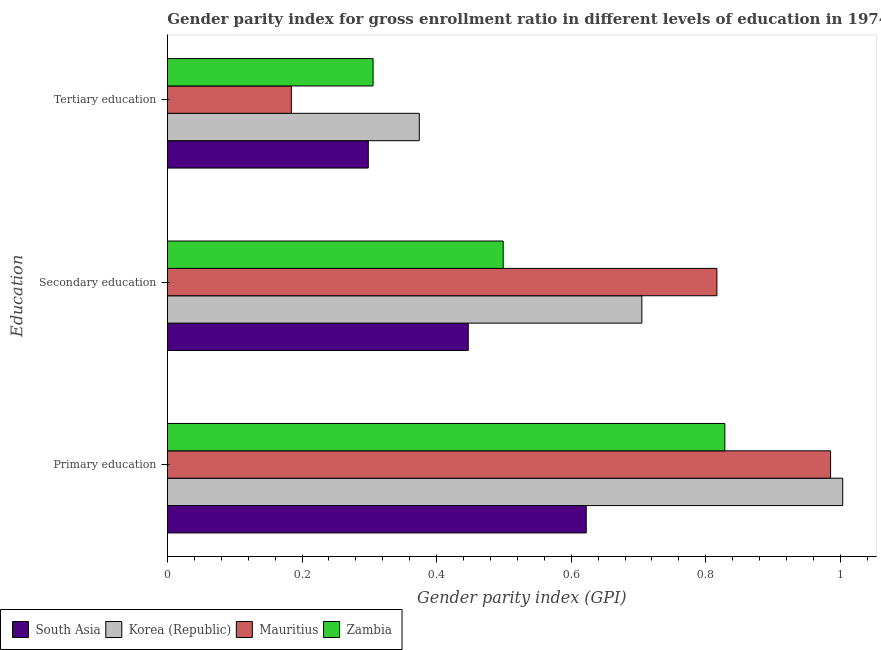How many groups of bars are there?
Your response must be concise. 3. How many bars are there on the 3rd tick from the top?
Ensure brevity in your answer.  4. How many bars are there on the 2nd tick from the bottom?
Give a very brief answer. 4. What is the label of the 2nd group of bars from the top?
Your answer should be very brief. Secondary education. What is the gender parity index in tertiary education in South Asia?
Provide a short and direct response. 0.3. Across all countries, what is the maximum gender parity index in tertiary education?
Your response must be concise. 0.37. Across all countries, what is the minimum gender parity index in tertiary education?
Your answer should be very brief. 0.18. In which country was the gender parity index in tertiary education maximum?
Provide a short and direct response. Korea (Republic). In which country was the gender parity index in tertiary education minimum?
Offer a very short reply. Mauritius. What is the total gender parity index in tertiary education in the graph?
Your answer should be compact. 1.16. What is the difference between the gender parity index in tertiary education in South Asia and that in Mauritius?
Offer a very short reply. 0.11. What is the difference between the gender parity index in secondary education in Zambia and the gender parity index in tertiary education in South Asia?
Make the answer very short. 0.2. What is the average gender parity index in secondary education per country?
Ensure brevity in your answer.  0.62. What is the difference between the gender parity index in secondary education and gender parity index in primary education in Mauritius?
Give a very brief answer. -0.17. In how many countries, is the gender parity index in secondary education greater than 0.68 ?
Your answer should be compact. 2. What is the ratio of the gender parity index in tertiary education in Korea (Republic) to that in Zambia?
Provide a succinct answer. 1.22. What is the difference between the highest and the second highest gender parity index in tertiary education?
Offer a terse response. 0.07. What is the difference between the highest and the lowest gender parity index in secondary education?
Provide a succinct answer. 0.37. In how many countries, is the gender parity index in tertiary education greater than the average gender parity index in tertiary education taken over all countries?
Provide a succinct answer. 3. Is the sum of the gender parity index in tertiary education in Zambia and Mauritius greater than the maximum gender parity index in secondary education across all countries?
Offer a terse response. No. What does the 1st bar from the top in Primary education represents?
Offer a terse response. Zambia. What does the 4th bar from the bottom in Primary education represents?
Provide a short and direct response. Zambia. Is it the case that in every country, the sum of the gender parity index in primary education and gender parity index in secondary education is greater than the gender parity index in tertiary education?
Your response must be concise. Yes. Are all the bars in the graph horizontal?
Offer a terse response. Yes. How many countries are there in the graph?
Give a very brief answer. 4. Are the values on the major ticks of X-axis written in scientific E-notation?
Keep it short and to the point. No. Does the graph contain any zero values?
Ensure brevity in your answer.  No. How many legend labels are there?
Offer a terse response. 4. What is the title of the graph?
Offer a terse response. Gender parity index for gross enrollment ratio in different levels of education in 1974. Does "Central African Republic" appear as one of the legend labels in the graph?
Your answer should be very brief. No. What is the label or title of the X-axis?
Keep it short and to the point. Gender parity index (GPI). What is the label or title of the Y-axis?
Make the answer very short. Education. What is the Gender parity index (GPI) in South Asia in Primary education?
Keep it short and to the point. 0.62. What is the Gender parity index (GPI) of Korea (Republic) in Primary education?
Provide a succinct answer. 1. What is the Gender parity index (GPI) of Mauritius in Primary education?
Your answer should be very brief. 0.99. What is the Gender parity index (GPI) of Zambia in Primary education?
Provide a short and direct response. 0.83. What is the Gender parity index (GPI) in South Asia in Secondary education?
Offer a terse response. 0.45. What is the Gender parity index (GPI) of Korea (Republic) in Secondary education?
Provide a short and direct response. 0.7. What is the Gender parity index (GPI) of Mauritius in Secondary education?
Provide a short and direct response. 0.82. What is the Gender parity index (GPI) of Zambia in Secondary education?
Ensure brevity in your answer.  0.5. What is the Gender parity index (GPI) of South Asia in Tertiary education?
Offer a terse response. 0.3. What is the Gender parity index (GPI) in Korea (Republic) in Tertiary education?
Your answer should be compact. 0.37. What is the Gender parity index (GPI) in Mauritius in Tertiary education?
Offer a terse response. 0.18. What is the Gender parity index (GPI) in Zambia in Tertiary education?
Give a very brief answer. 0.31. Across all Education, what is the maximum Gender parity index (GPI) in South Asia?
Your response must be concise. 0.62. Across all Education, what is the maximum Gender parity index (GPI) of Korea (Republic)?
Your answer should be compact. 1. Across all Education, what is the maximum Gender parity index (GPI) in Mauritius?
Offer a terse response. 0.99. Across all Education, what is the maximum Gender parity index (GPI) in Zambia?
Keep it short and to the point. 0.83. Across all Education, what is the minimum Gender parity index (GPI) in South Asia?
Give a very brief answer. 0.3. Across all Education, what is the minimum Gender parity index (GPI) of Korea (Republic)?
Offer a very short reply. 0.37. Across all Education, what is the minimum Gender parity index (GPI) of Mauritius?
Provide a succinct answer. 0.18. Across all Education, what is the minimum Gender parity index (GPI) in Zambia?
Provide a short and direct response. 0.31. What is the total Gender parity index (GPI) of South Asia in the graph?
Your answer should be compact. 1.37. What is the total Gender parity index (GPI) of Korea (Republic) in the graph?
Your answer should be compact. 2.08. What is the total Gender parity index (GPI) of Mauritius in the graph?
Your answer should be compact. 1.99. What is the total Gender parity index (GPI) in Zambia in the graph?
Provide a succinct answer. 1.63. What is the difference between the Gender parity index (GPI) in South Asia in Primary education and that in Secondary education?
Keep it short and to the point. 0.18. What is the difference between the Gender parity index (GPI) of Korea (Republic) in Primary education and that in Secondary education?
Offer a very short reply. 0.3. What is the difference between the Gender parity index (GPI) in Mauritius in Primary education and that in Secondary education?
Your response must be concise. 0.17. What is the difference between the Gender parity index (GPI) in Zambia in Primary education and that in Secondary education?
Make the answer very short. 0.33. What is the difference between the Gender parity index (GPI) in South Asia in Primary education and that in Tertiary education?
Give a very brief answer. 0.32. What is the difference between the Gender parity index (GPI) in Korea (Republic) in Primary education and that in Tertiary education?
Your answer should be very brief. 0.63. What is the difference between the Gender parity index (GPI) of Mauritius in Primary education and that in Tertiary education?
Provide a succinct answer. 0.8. What is the difference between the Gender parity index (GPI) in Zambia in Primary education and that in Tertiary education?
Your answer should be very brief. 0.52. What is the difference between the Gender parity index (GPI) of South Asia in Secondary education and that in Tertiary education?
Make the answer very short. 0.15. What is the difference between the Gender parity index (GPI) of Korea (Republic) in Secondary education and that in Tertiary education?
Offer a very short reply. 0.33. What is the difference between the Gender parity index (GPI) in Mauritius in Secondary education and that in Tertiary education?
Give a very brief answer. 0.63. What is the difference between the Gender parity index (GPI) of Zambia in Secondary education and that in Tertiary education?
Keep it short and to the point. 0.19. What is the difference between the Gender parity index (GPI) in South Asia in Primary education and the Gender parity index (GPI) in Korea (Republic) in Secondary education?
Your response must be concise. -0.08. What is the difference between the Gender parity index (GPI) in South Asia in Primary education and the Gender parity index (GPI) in Mauritius in Secondary education?
Provide a short and direct response. -0.19. What is the difference between the Gender parity index (GPI) of South Asia in Primary education and the Gender parity index (GPI) of Zambia in Secondary education?
Ensure brevity in your answer.  0.12. What is the difference between the Gender parity index (GPI) of Korea (Republic) in Primary education and the Gender parity index (GPI) of Mauritius in Secondary education?
Provide a short and direct response. 0.19. What is the difference between the Gender parity index (GPI) in Korea (Republic) in Primary education and the Gender parity index (GPI) in Zambia in Secondary education?
Provide a short and direct response. 0.5. What is the difference between the Gender parity index (GPI) of Mauritius in Primary education and the Gender parity index (GPI) of Zambia in Secondary education?
Offer a terse response. 0.49. What is the difference between the Gender parity index (GPI) in South Asia in Primary education and the Gender parity index (GPI) in Korea (Republic) in Tertiary education?
Provide a succinct answer. 0.25. What is the difference between the Gender parity index (GPI) of South Asia in Primary education and the Gender parity index (GPI) of Mauritius in Tertiary education?
Your answer should be compact. 0.44. What is the difference between the Gender parity index (GPI) in South Asia in Primary education and the Gender parity index (GPI) in Zambia in Tertiary education?
Your response must be concise. 0.32. What is the difference between the Gender parity index (GPI) of Korea (Republic) in Primary education and the Gender parity index (GPI) of Mauritius in Tertiary education?
Offer a terse response. 0.82. What is the difference between the Gender parity index (GPI) in Korea (Republic) in Primary education and the Gender parity index (GPI) in Zambia in Tertiary education?
Your answer should be very brief. 0.7. What is the difference between the Gender parity index (GPI) in Mauritius in Primary education and the Gender parity index (GPI) in Zambia in Tertiary education?
Provide a succinct answer. 0.68. What is the difference between the Gender parity index (GPI) in South Asia in Secondary education and the Gender parity index (GPI) in Korea (Republic) in Tertiary education?
Offer a very short reply. 0.07. What is the difference between the Gender parity index (GPI) in South Asia in Secondary education and the Gender parity index (GPI) in Mauritius in Tertiary education?
Ensure brevity in your answer.  0.26. What is the difference between the Gender parity index (GPI) in South Asia in Secondary education and the Gender parity index (GPI) in Zambia in Tertiary education?
Your answer should be very brief. 0.14. What is the difference between the Gender parity index (GPI) in Korea (Republic) in Secondary education and the Gender parity index (GPI) in Mauritius in Tertiary education?
Make the answer very short. 0.52. What is the difference between the Gender parity index (GPI) in Korea (Republic) in Secondary education and the Gender parity index (GPI) in Zambia in Tertiary education?
Your answer should be compact. 0.4. What is the difference between the Gender parity index (GPI) in Mauritius in Secondary education and the Gender parity index (GPI) in Zambia in Tertiary education?
Make the answer very short. 0.51. What is the average Gender parity index (GPI) of South Asia per Education?
Your answer should be compact. 0.46. What is the average Gender parity index (GPI) in Korea (Republic) per Education?
Keep it short and to the point. 0.69. What is the average Gender parity index (GPI) of Mauritius per Education?
Offer a very short reply. 0.66. What is the average Gender parity index (GPI) of Zambia per Education?
Offer a terse response. 0.54. What is the difference between the Gender parity index (GPI) in South Asia and Gender parity index (GPI) in Korea (Republic) in Primary education?
Give a very brief answer. -0.38. What is the difference between the Gender parity index (GPI) of South Asia and Gender parity index (GPI) of Mauritius in Primary education?
Ensure brevity in your answer.  -0.36. What is the difference between the Gender parity index (GPI) of South Asia and Gender parity index (GPI) of Zambia in Primary education?
Your response must be concise. -0.21. What is the difference between the Gender parity index (GPI) in Korea (Republic) and Gender parity index (GPI) in Mauritius in Primary education?
Keep it short and to the point. 0.02. What is the difference between the Gender parity index (GPI) in Korea (Republic) and Gender parity index (GPI) in Zambia in Primary education?
Make the answer very short. 0.18. What is the difference between the Gender parity index (GPI) of Mauritius and Gender parity index (GPI) of Zambia in Primary education?
Make the answer very short. 0.16. What is the difference between the Gender parity index (GPI) in South Asia and Gender parity index (GPI) in Korea (Republic) in Secondary education?
Offer a terse response. -0.26. What is the difference between the Gender parity index (GPI) in South Asia and Gender parity index (GPI) in Mauritius in Secondary education?
Your answer should be very brief. -0.37. What is the difference between the Gender parity index (GPI) of South Asia and Gender parity index (GPI) of Zambia in Secondary education?
Your answer should be compact. -0.05. What is the difference between the Gender parity index (GPI) in Korea (Republic) and Gender parity index (GPI) in Mauritius in Secondary education?
Offer a terse response. -0.11. What is the difference between the Gender parity index (GPI) in Korea (Republic) and Gender parity index (GPI) in Zambia in Secondary education?
Make the answer very short. 0.21. What is the difference between the Gender parity index (GPI) in Mauritius and Gender parity index (GPI) in Zambia in Secondary education?
Your response must be concise. 0.32. What is the difference between the Gender parity index (GPI) in South Asia and Gender parity index (GPI) in Korea (Republic) in Tertiary education?
Your answer should be very brief. -0.08. What is the difference between the Gender parity index (GPI) of South Asia and Gender parity index (GPI) of Mauritius in Tertiary education?
Your response must be concise. 0.11. What is the difference between the Gender parity index (GPI) of South Asia and Gender parity index (GPI) of Zambia in Tertiary education?
Provide a succinct answer. -0.01. What is the difference between the Gender parity index (GPI) of Korea (Republic) and Gender parity index (GPI) of Mauritius in Tertiary education?
Give a very brief answer. 0.19. What is the difference between the Gender parity index (GPI) of Korea (Republic) and Gender parity index (GPI) of Zambia in Tertiary education?
Provide a succinct answer. 0.07. What is the difference between the Gender parity index (GPI) of Mauritius and Gender parity index (GPI) of Zambia in Tertiary education?
Ensure brevity in your answer.  -0.12. What is the ratio of the Gender parity index (GPI) of South Asia in Primary education to that in Secondary education?
Your response must be concise. 1.39. What is the ratio of the Gender parity index (GPI) of Korea (Republic) in Primary education to that in Secondary education?
Give a very brief answer. 1.42. What is the ratio of the Gender parity index (GPI) of Mauritius in Primary education to that in Secondary education?
Keep it short and to the point. 1.21. What is the ratio of the Gender parity index (GPI) of Zambia in Primary education to that in Secondary education?
Your answer should be very brief. 1.66. What is the ratio of the Gender parity index (GPI) of South Asia in Primary education to that in Tertiary education?
Your answer should be compact. 2.08. What is the ratio of the Gender parity index (GPI) in Korea (Republic) in Primary education to that in Tertiary education?
Your answer should be very brief. 2.68. What is the ratio of the Gender parity index (GPI) in Mauritius in Primary education to that in Tertiary education?
Keep it short and to the point. 5.35. What is the ratio of the Gender parity index (GPI) of Zambia in Primary education to that in Tertiary education?
Give a very brief answer. 2.71. What is the ratio of the Gender parity index (GPI) of South Asia in Secondary education to that in Tertiary education?
Keep it short and to the point. 1.5. What is the ratio of the Gender parity index (GPI) in Korea (Republic) in Secondary education to that in Tertiary education?
Keep it short and to the point. 1.88. What is the ratio of the Gender parity index (GPI) in Mauritius in Secondary education to that in Tertiary education?
Give a very brief answer. 4.43. What is the ratio of the Gender parity index (GPI) in Zambia in Secondary education to that in Tertiary education?
Ensure brevity in your answer.  1.63. What is the difference between the highest and the second highest Gender parity index (GPI) in South Asia?
Provide a short and direct response. 0.18. What is the difference between the highest and the second highest Gender parity index (GPI) in Korea (Republic)?
Ensure brevity in your answer.  0.3. What is the difference between the highest and the second highest Gender parity index (GPI) in Mauritius?
Give a very brief answer. 0.17. What is the difference between the highest and the second highest Gender parity index (GPI) in Zambia?
Ensure brevity in your answer.  0.33. What is the difference between the highest and the lowest Gender parity index (GPI) in South Asia?
Your answer should be compact. 0.32. What is the difference between the highest and the lowest Gender parity index (GPI) of Korea (Republic)?
Make the answer very short. 0.63. What is the difference between the highest and the lowest Gender parity index (GPI) of Mauritius?
Ensure brevity in your answer.  0.8. What is the difference between the highest and the lowest Gender parity index (GPI) of Zambia?
Your response must be concise. 0.52. 